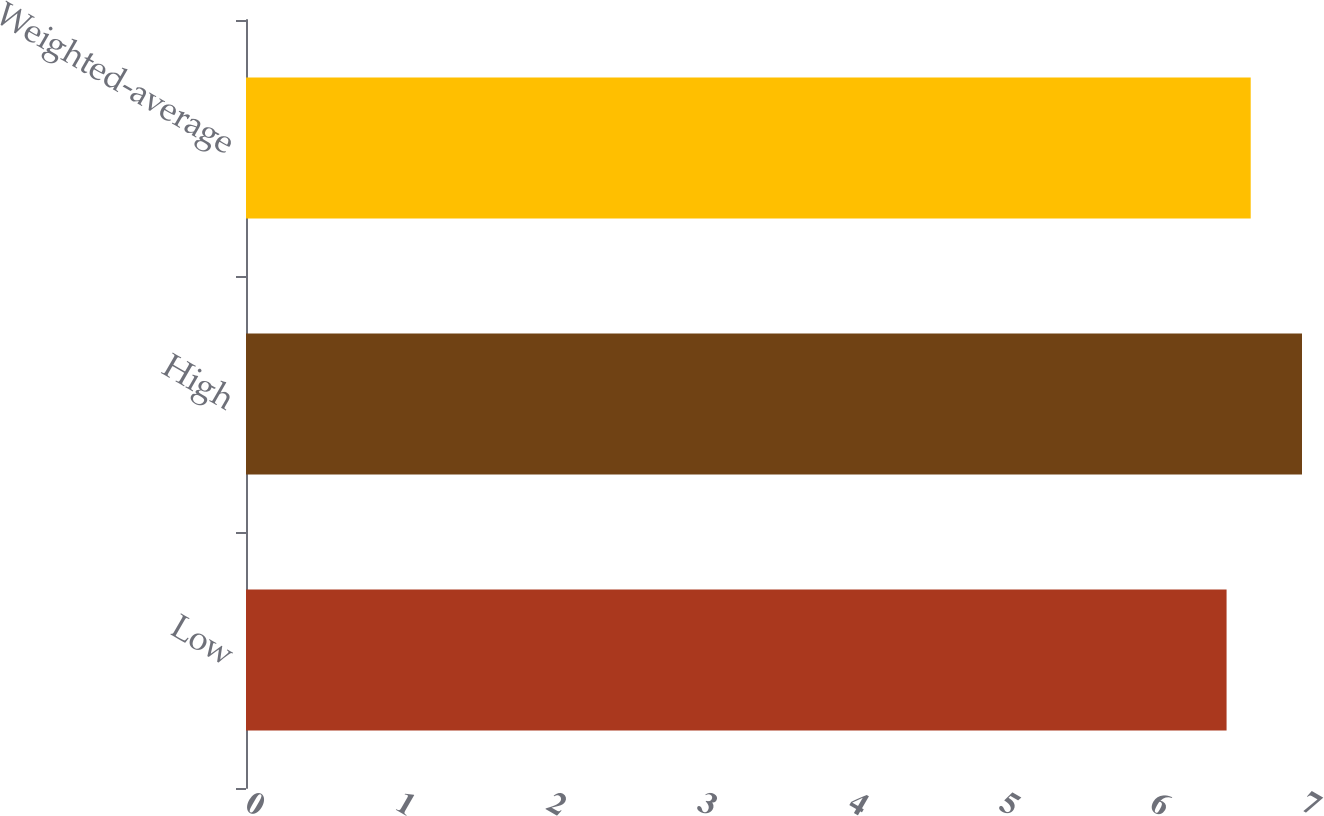Convert chart to OTSL. <chart><loc_0><loc_0><loc_500><loc_500><bar_chart><fcel>Low<fcel>High<fcel>Weighted-average<nl><fcel>6.5<fcel>7<fcel>6.66<nl></chart> 